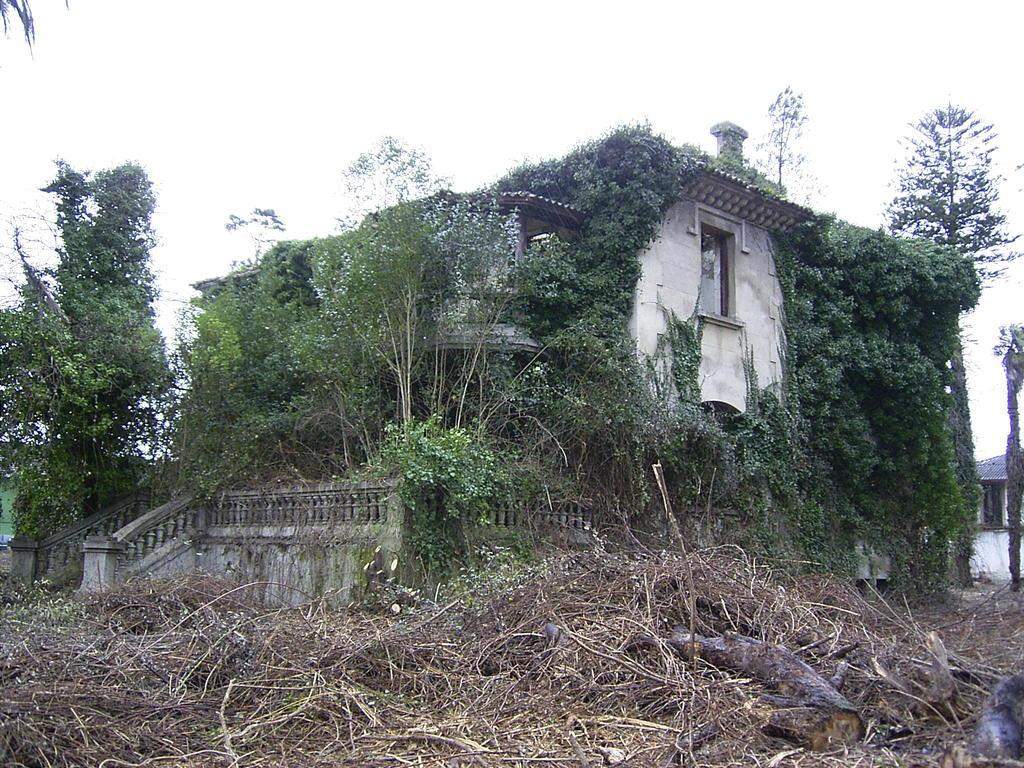What is the main structure in the image? There is a building in the middle of the image. What type of natural elements are present around the building? There are trees around the building. What is visible at the top of the image? The sky is visible at the top of the image. How many rabbits can be seen playing with a wrench in the image? There are no rabbits or wrenches present in the image. Is there a receipt visible in the image? There is no receipt present in the image. 